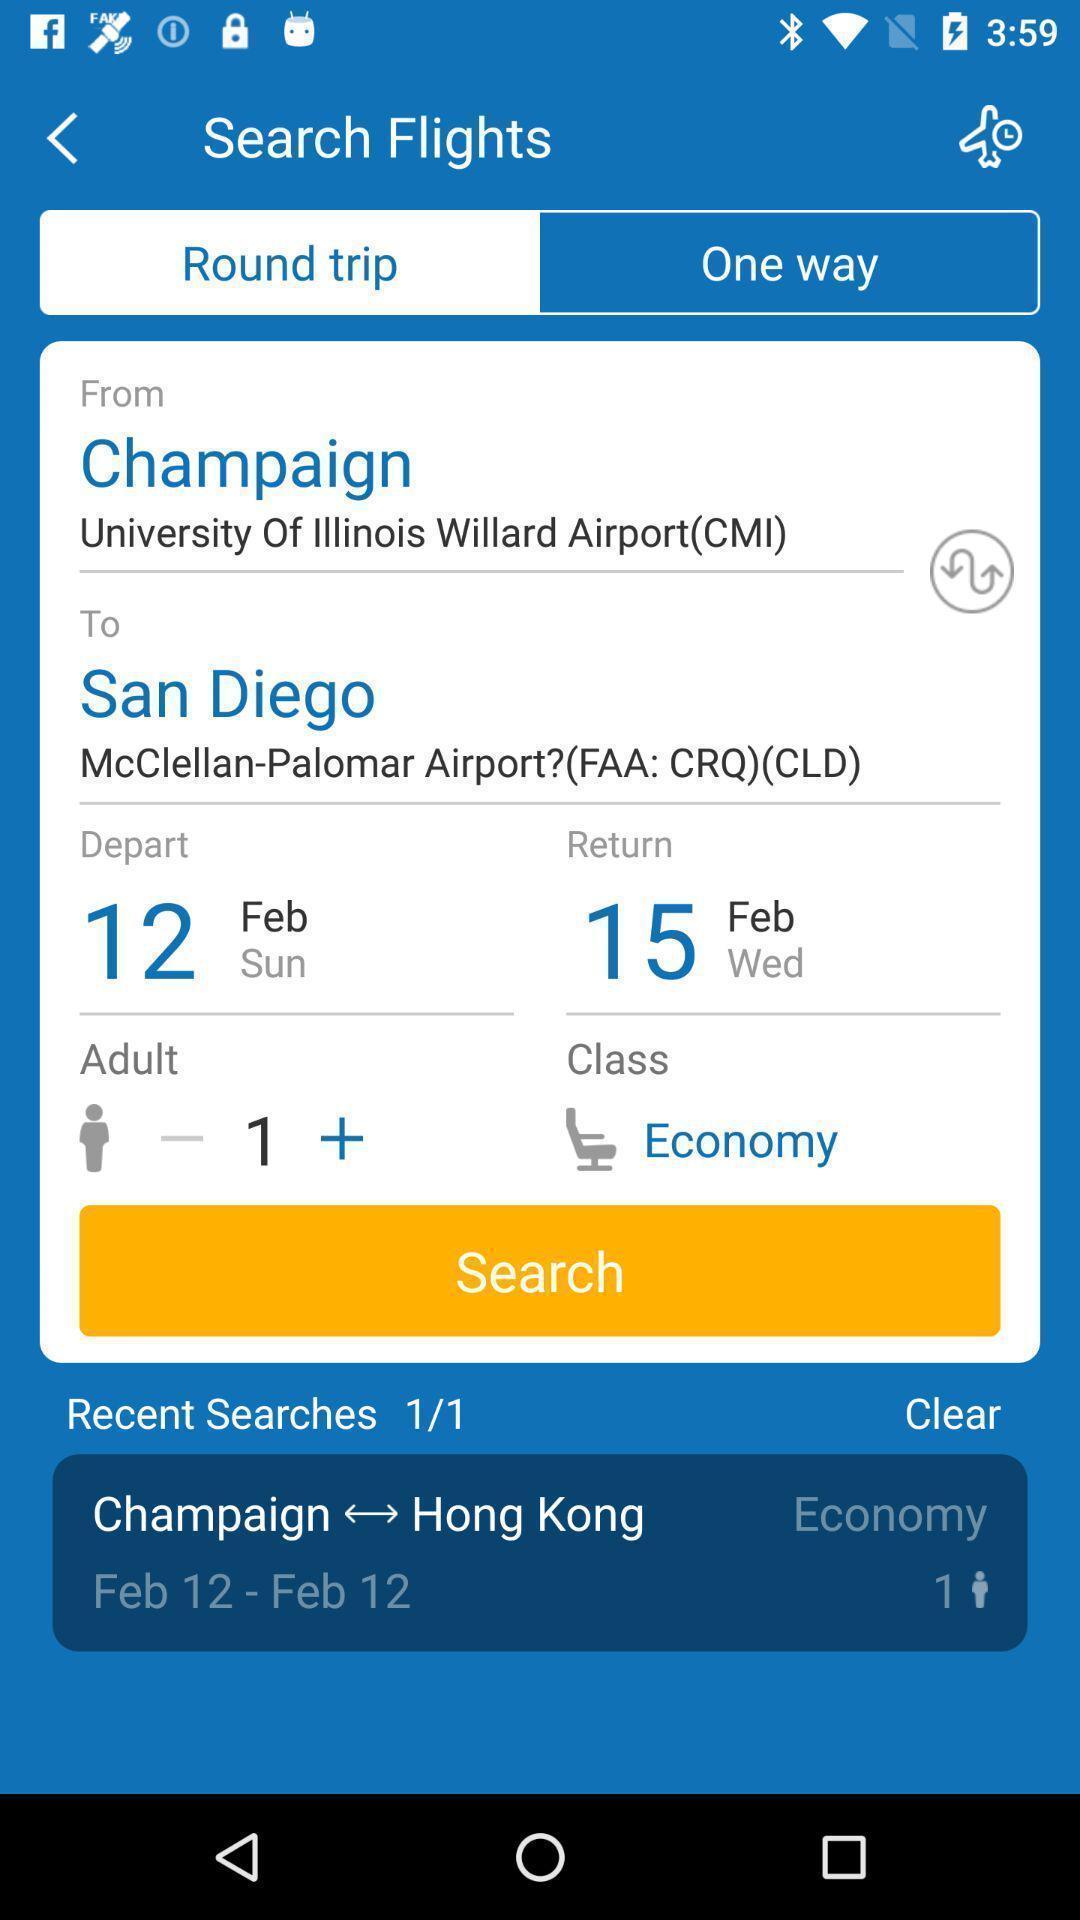Provide a description of this screenshot. Screen showing round trip. 